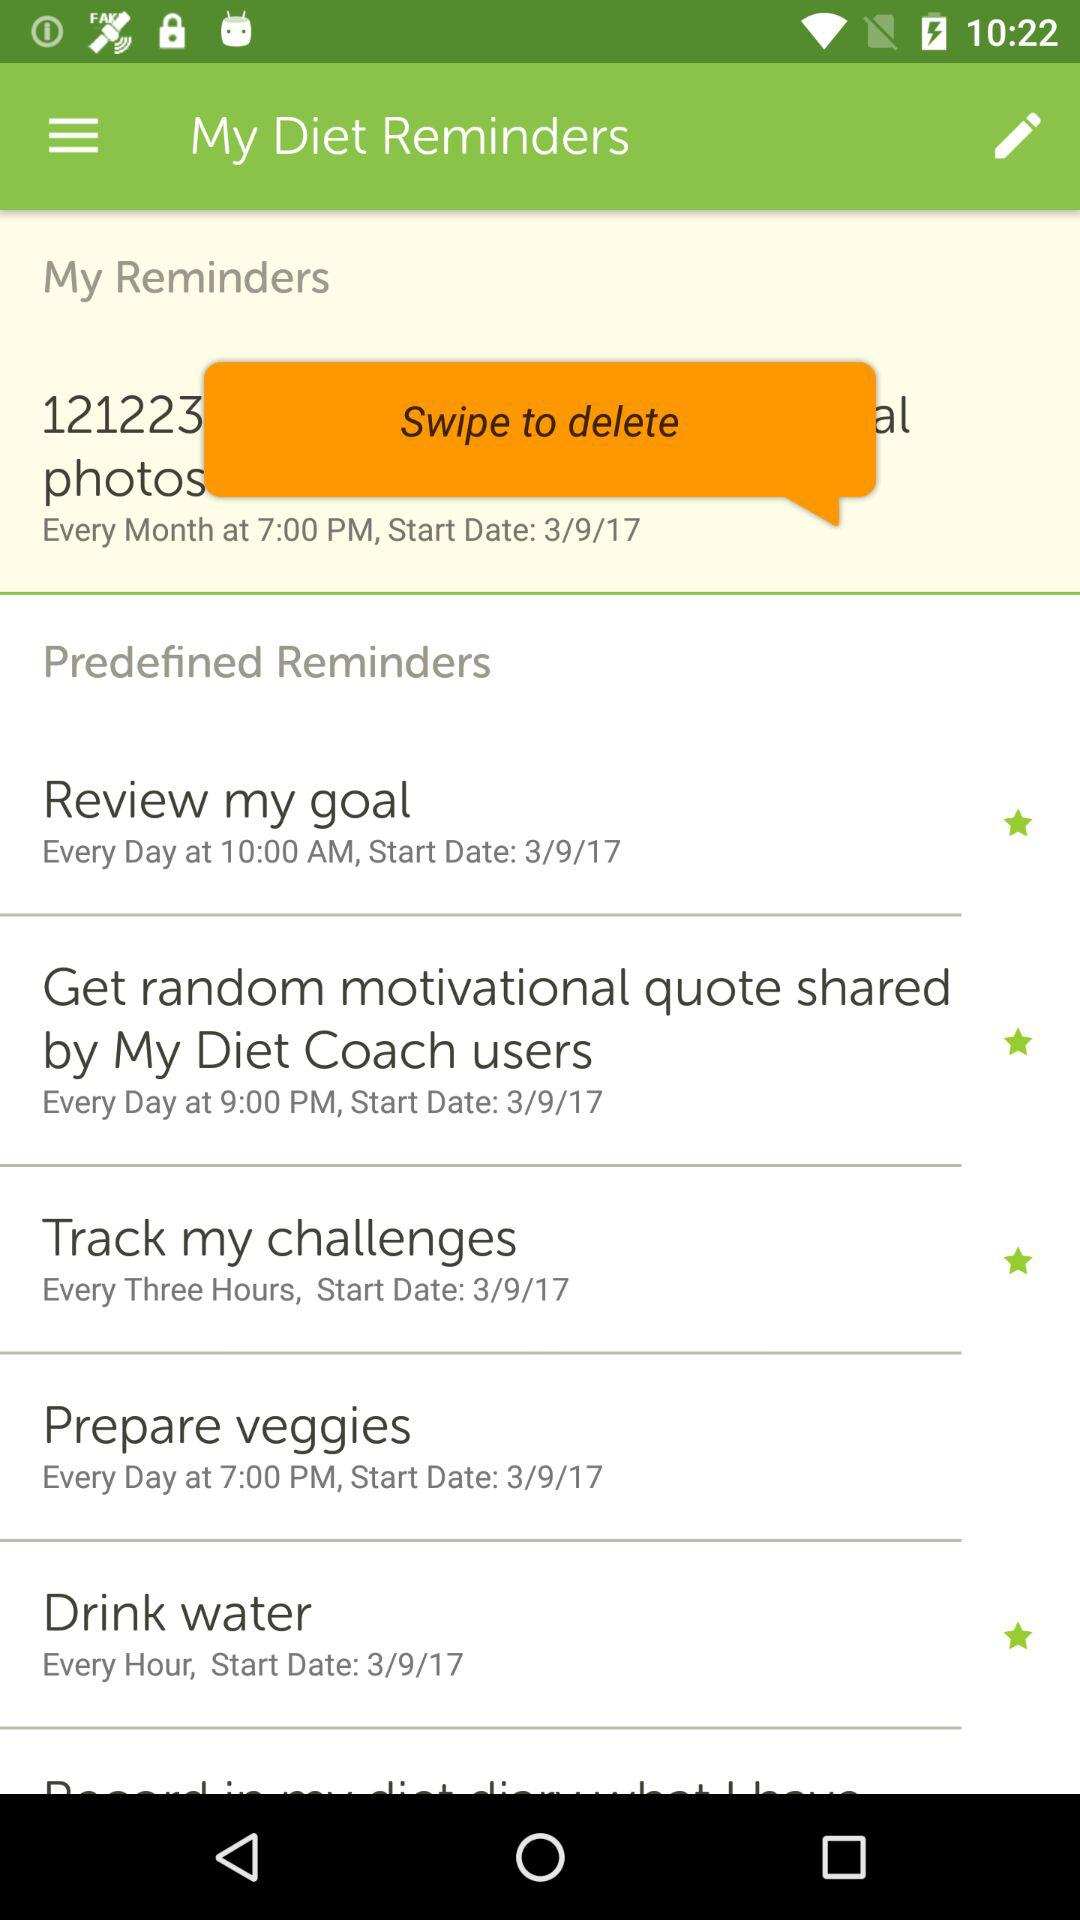What is the frequency for tracking my challenges? The frequency for tracking my challenges is every three hours. 